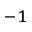<formula> <loc_0><loc_0><loc_500><loc_500>^ { - 1 }</formula> 